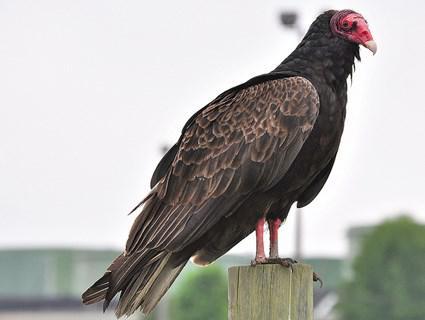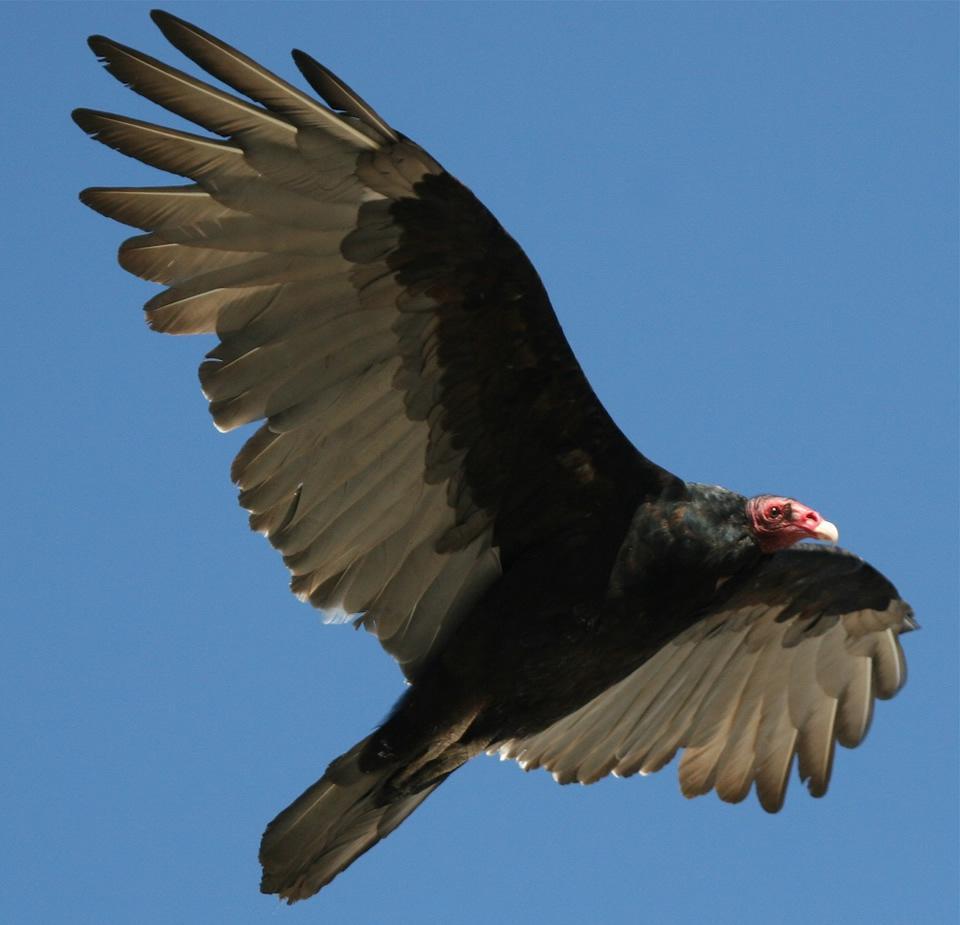The first image is the image on the left, the second image is the image on the right. Analyze the images presented: Is the assertion "An image shows a vulture standing on a kind of perch." valid? Answer yes or no. Yes. 